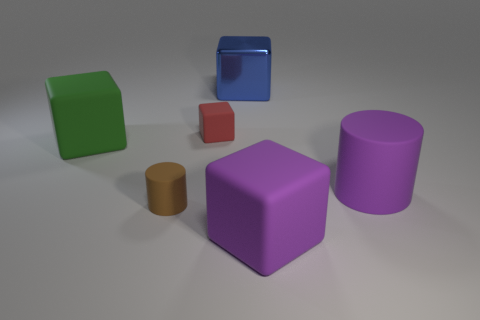How many other objects are the same material as the blue thing?
Make the answer very short. 0. There is a cylinder that is on the right side of the red rubber cube; does it have the same color as the small matte cylinder?
Your response must be concise. No. Is there a cylinder that is right of the rubber thing behind the large green thing?
Offer a terse response. Yes. What material is the cube that is both in front of the blue metal cube and to the right of the red matte thing?
Provide a short and direct response. Rubber. What is the shape of the small red thing that is made of the same material as the green thing?
Offer a very short reply. Cube. Does the cylinder that is on the left side of the small red thing have the same material as the blue thing?
Keep it short and to the point. No. What is the material of the large block that is to the right of the big blue thing?
Your answer should be compact. Rubber. What size is the green thing that is to the left of the rubber block that is behind the big green block?
Your answer should be very brief. Large. How many objects are the same size as the red rubber block?
Make the answer very short. 1. Is the color of the big cube to the right of the big blue shiny cube the same as the rubber cylinder behind the tiny brown rubber cylinder?
Keep it short and to the point. Yes. 